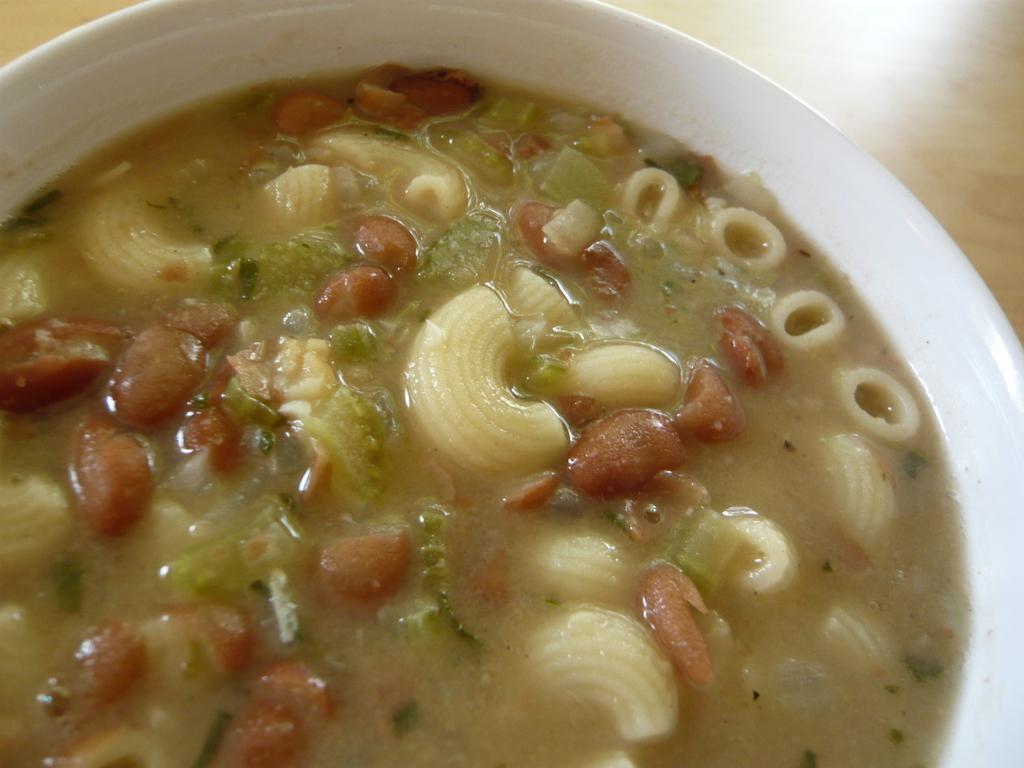Please provide a concise description of this image. In this picture I can observe some food in the white color bowl. The food is in yellow and red color. This bowl is placed on the brown color table. 